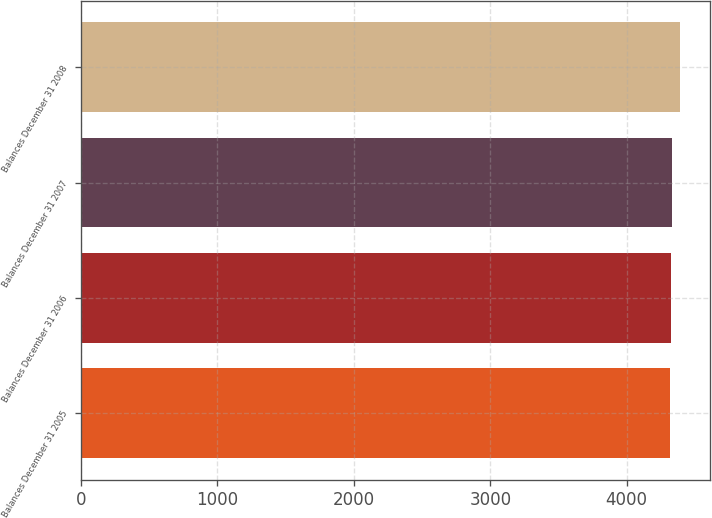Convert chart to OTSL. <chart><loc_0><loc_0><loc_500><loc_500><bar_chart><fcel>Balances December 31 2005<fcel>Balances December 31 2006<fcel>Balances December 31 2007<fcel>Balances December 31 2008<nl><fcel>4318<fcel>4325.5<fcel>4333<fcel>4393<nl></chart> 